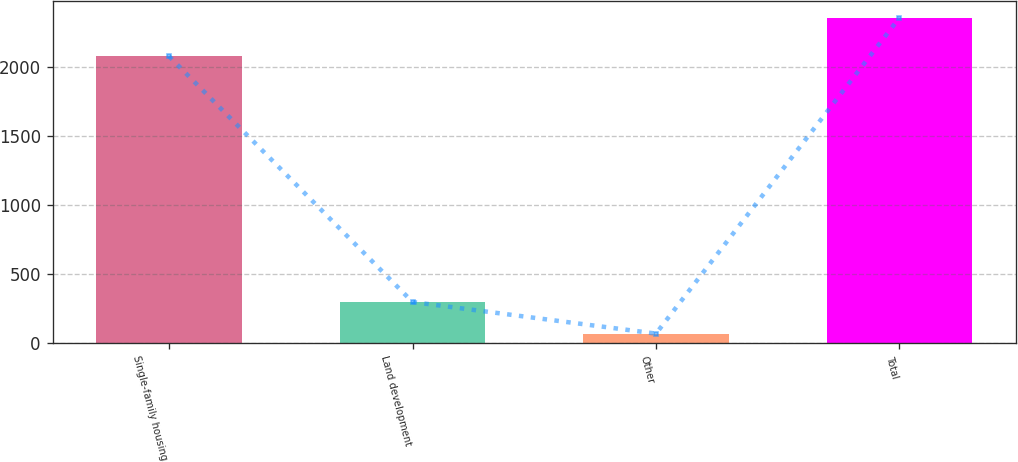Convert chart to OTSL. <chart><loc_0><loc_0><loc_500><loc_500><bar_chart><fcel>Single-family housing<fcel>Land development<fcel>Other<fcel>Total<nl><fcel>2079<fcel>296.2<fcel>67<fcel>2359<nl></chart> 